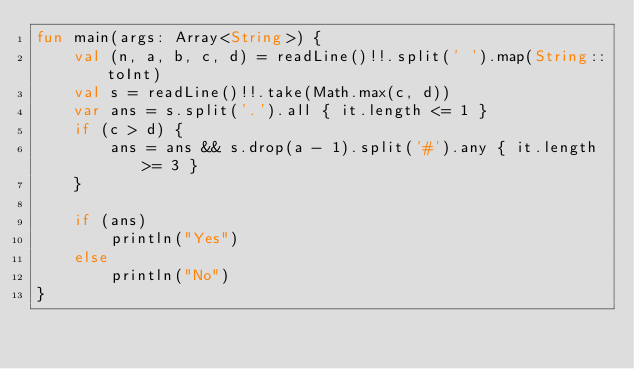Convert code to text. <code><loc_0><loc_0><loc_500><loc_500><_Kotlin_>fun main(args: Array<String>) {
    val (n, a, b, c, d) = readLine()!!.split(' ').map(String::toInt)
    val s = readLine()!!.take(Math.max(c, d))
    var ans = s.split('.').all { it.length <= 1 }
    if (c > d) {
        ans = ans && s.drop(a - 1).split('#').any { it.length >= 3 }
    }

    if (ans)
        println("Yes")
    else
        println("No")
}
</code> 